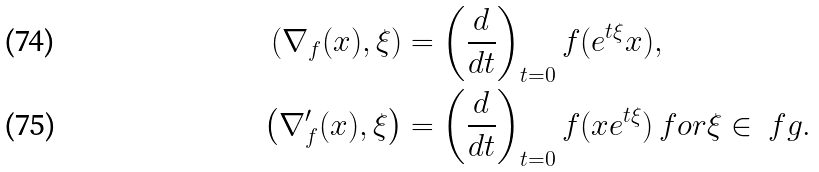<formula> <loc_0><loc_0><loc_500><loc_500>\left ( \nabla _ { f } ( x ) , \xi \right ) & = \left ( \frac { d } { d t } \right ) _ { t = 0 } f ( e ^ { t \xi } x ) , \\ \left ( \nabla ^ { \prime } _ { f } ( x ) , \xi \right ) & = \left ( \frac { d } { d t } \right ) _ { t = 0 } f ( x e ^ { t \xi } ) \, f o r \xi \in \ f g .</formula> 